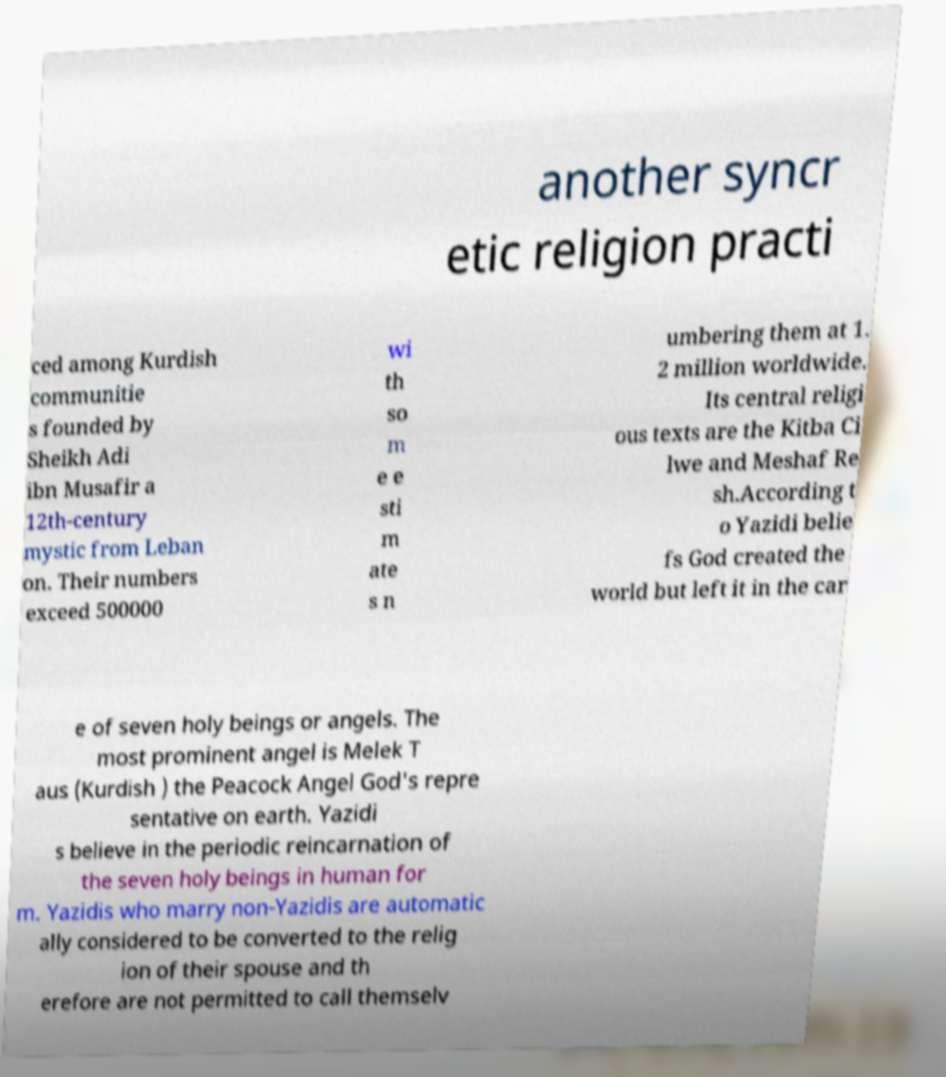For documentation purposes, I need the text within this image transcribed. Could you provide that? another syncr etic religion practi ced among Kurdish communitie s founded by Sheikh Adi ibn Musafir a 12th-century mystic from Leban on. Their numbers exceed 500000 wi th so m e e sti m ate s n umbering them at 1. 2 million worldwide. Its central religi ous texts are the Kitba Ci lwe and Meshaf Re sh.According t o Yazidi belie fs God created the world but left it in the car e of seven holy beings or angels. The most prominent angel is Melek T aus (Kurdish ) the Peacock Angel God's repre sentative on earth. Yazidi s believe in the periodic reincarnation of the seven holy beings in human for m. Yazidis who marry non-Yazidis are automatic ally considered to be converted to the relig ion of their spouse and th erefore are not permitted to call themselv 